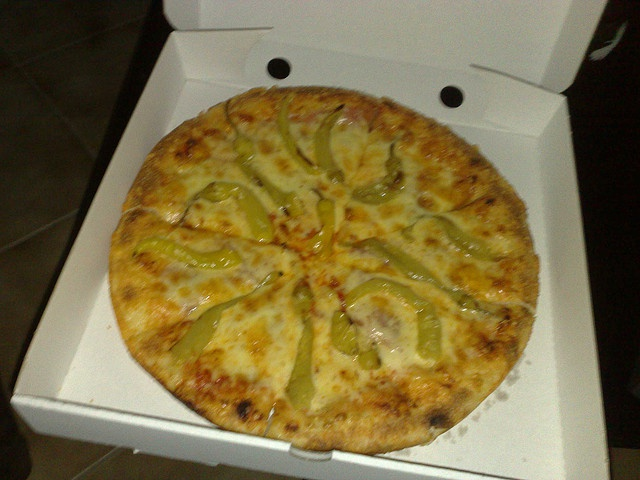Describe the objects in this image and their specific colors. I can see a pizza in black and olive tones in this image. 